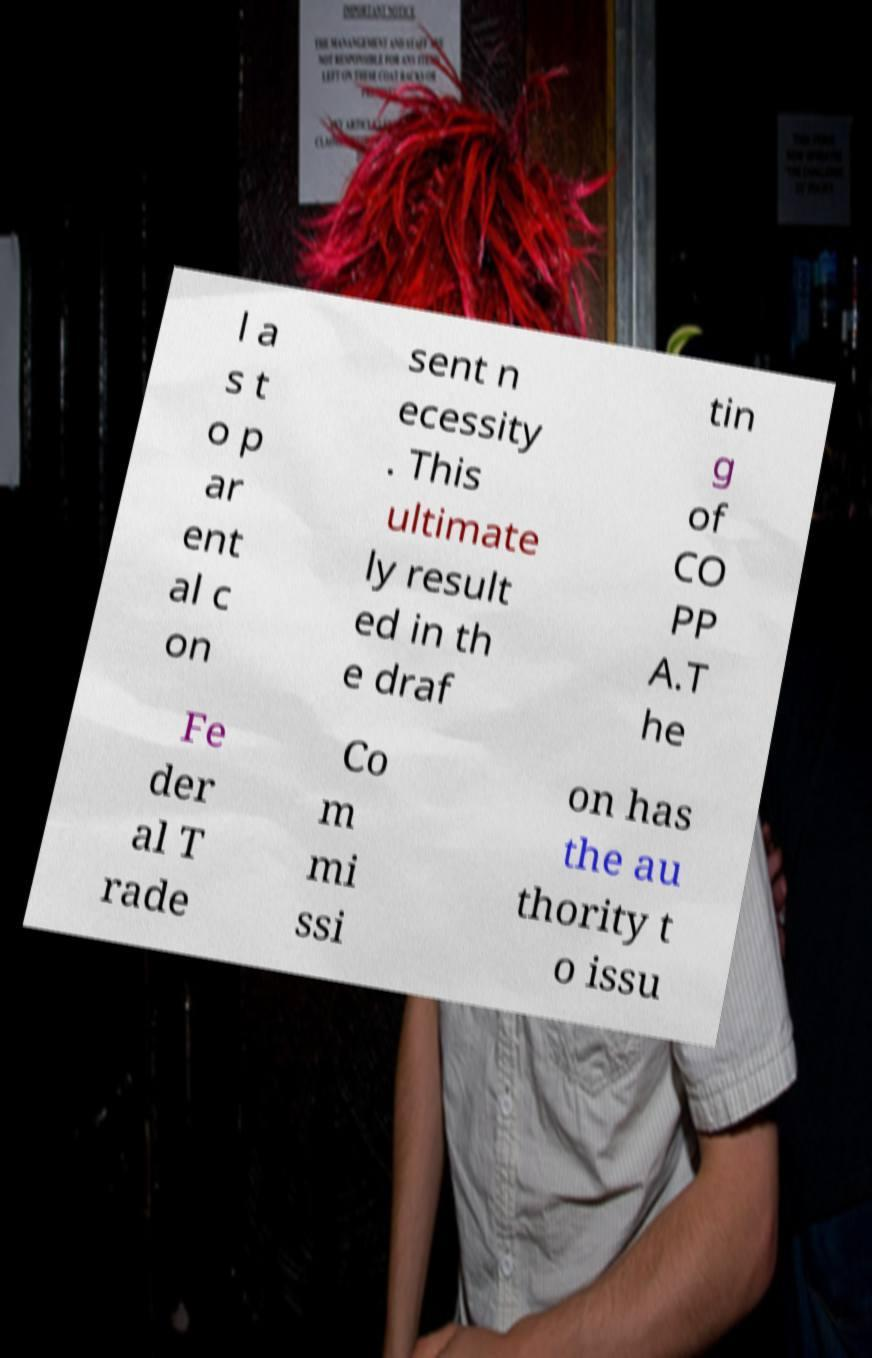Can you read and provide the text displayed in the image?This photo seems to have some interesting text. Can you extract and type it out for me? l a s t o p ar ent al c on sent n ecessity . This ultimate ly result ed in th e draf tin g of CO PP A.T he Fe der al T rade Co m mi ssi on has the au thority t o issu 